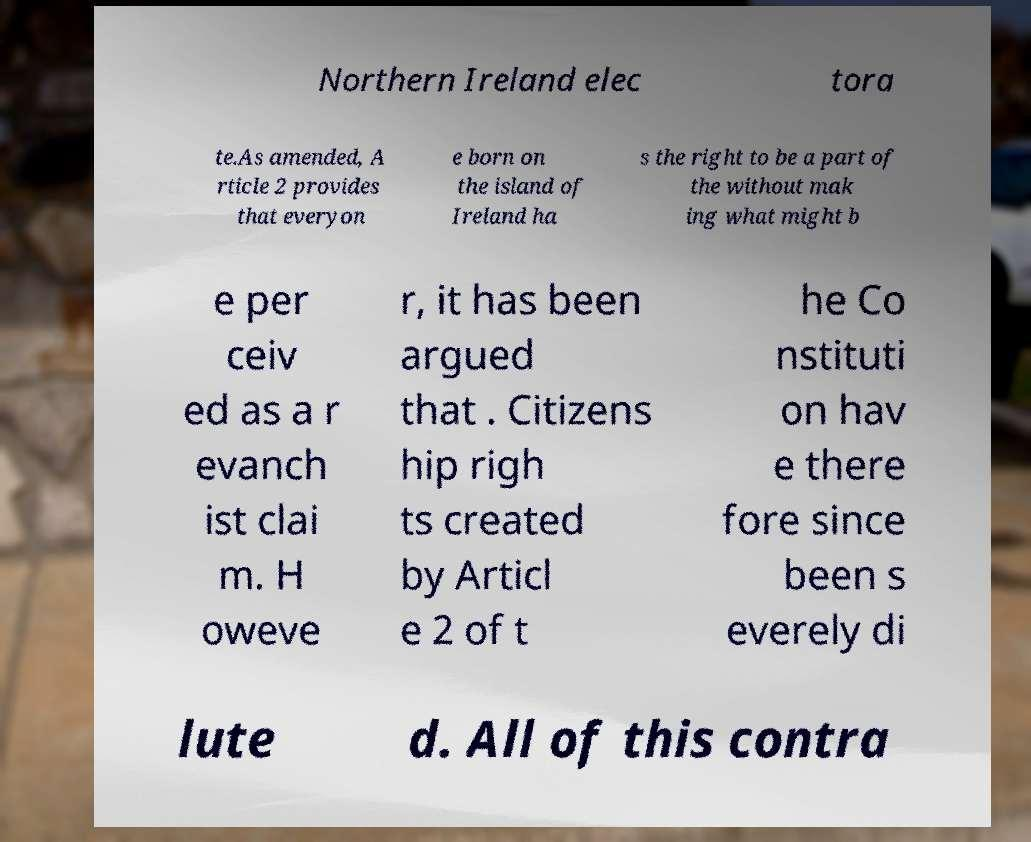Can you read and provide the text displayed in the image?This photo seems to have some interesting text. Can you extract and type it out for me? Northern Ireland elec tora te.As amended, A rticle 2 provides that everyon e born on the island of Ireland ha s the right to be a part of the without mak ing what might b e per ceiv ed as a r evanch ist clai m. H oweve r, it has been argued that . Citizens hip righ ts created by Articl e 2 of t he Co nstituti on hav e there fore since been s everely di lute d. All of this contra 